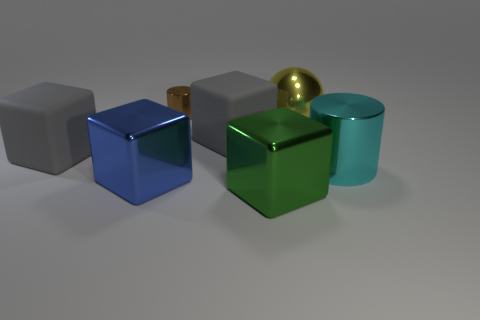Subtract 2 blocks. How many blocks are left? 2 Add 1 small metal things. How many objects exist? 8 Subtract all purple blocks. Subtract all red spheres. How many blocks are left? 4 Subtract all blocks. How many objects are left? 3 Add 5 yellow things. How many yellow things are left? 6 Add 5 small cylinders. How many small cylinders exist? 6 Subtract 0 blue cylinders. How many objects are left? 7 Subtract all large cyan objects. Subtract all big cylinders. How many objects are left? 5 